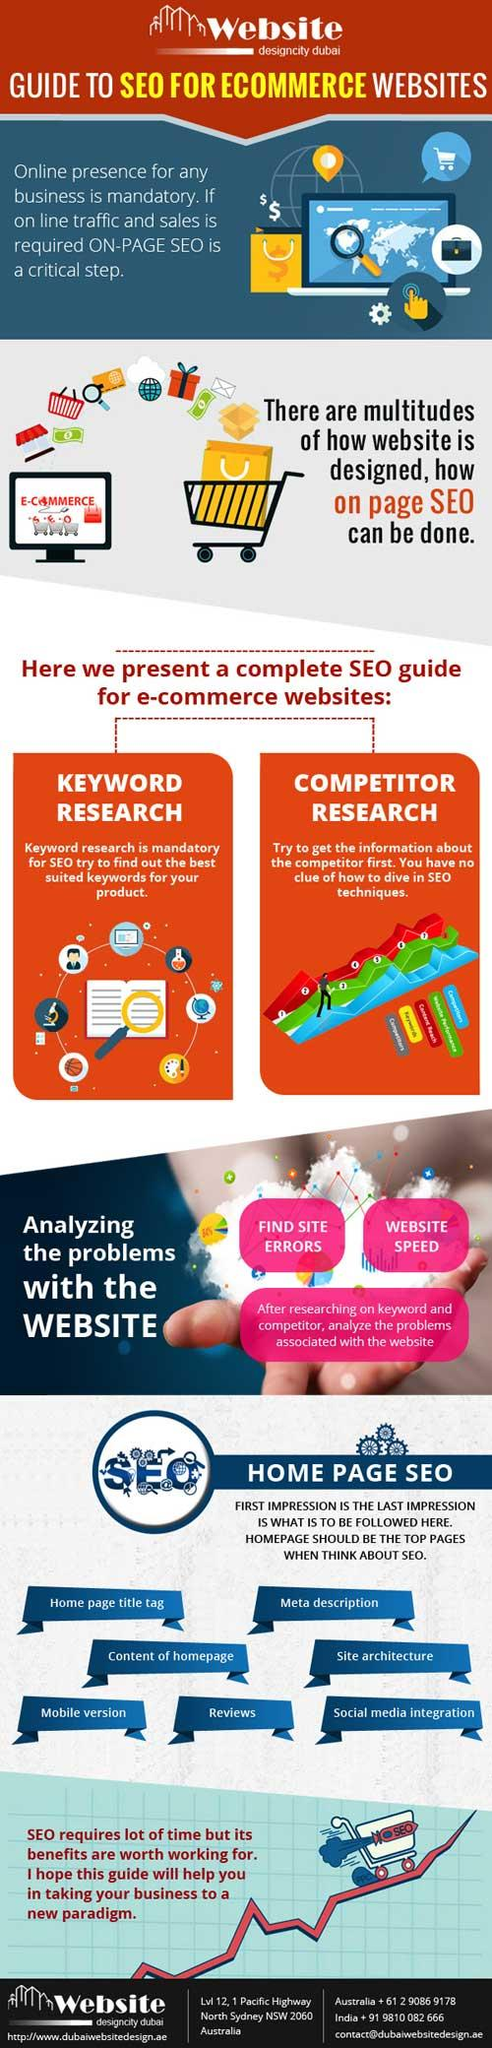Indicate a few pertinent items in this graphic. The second last tip mentioned that helps to improve homepage SEO is reviews. Keyword research is an essential tool for identifying appropriate keywords for a product's search engine optimization. 